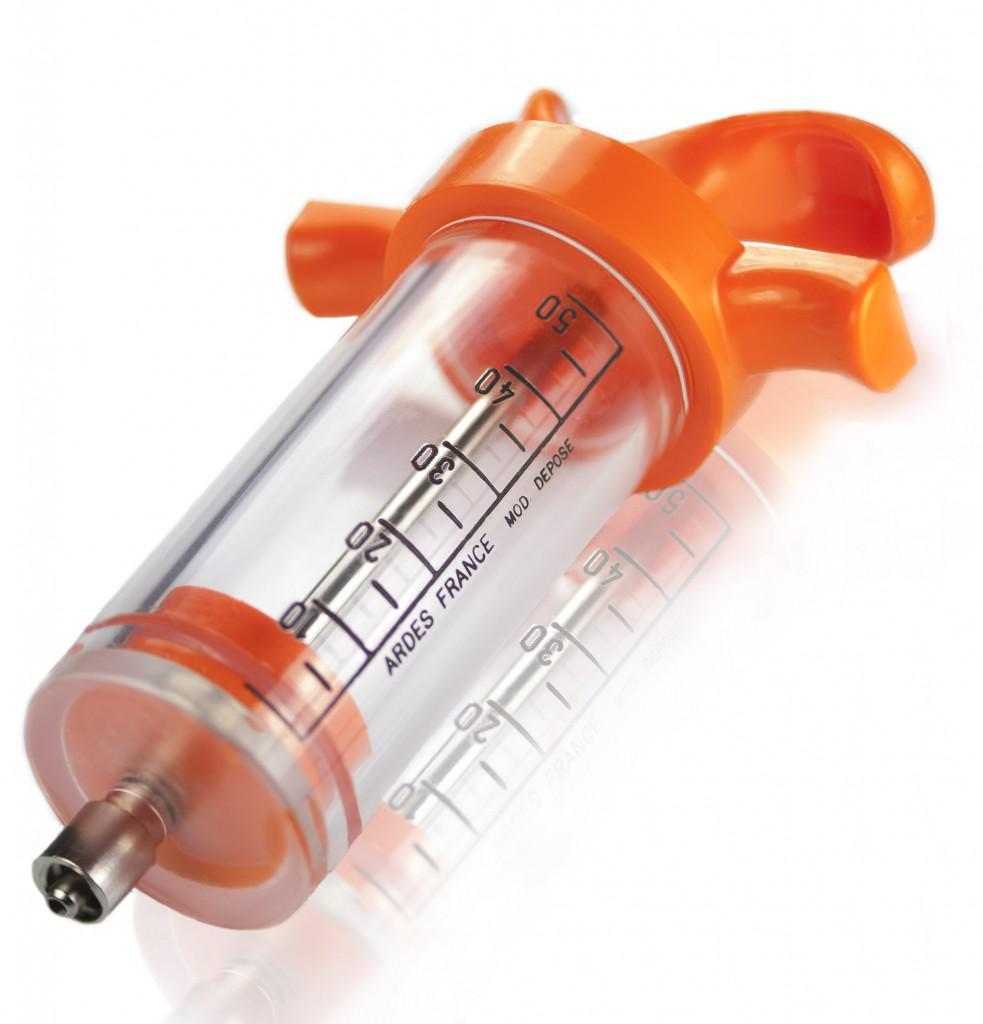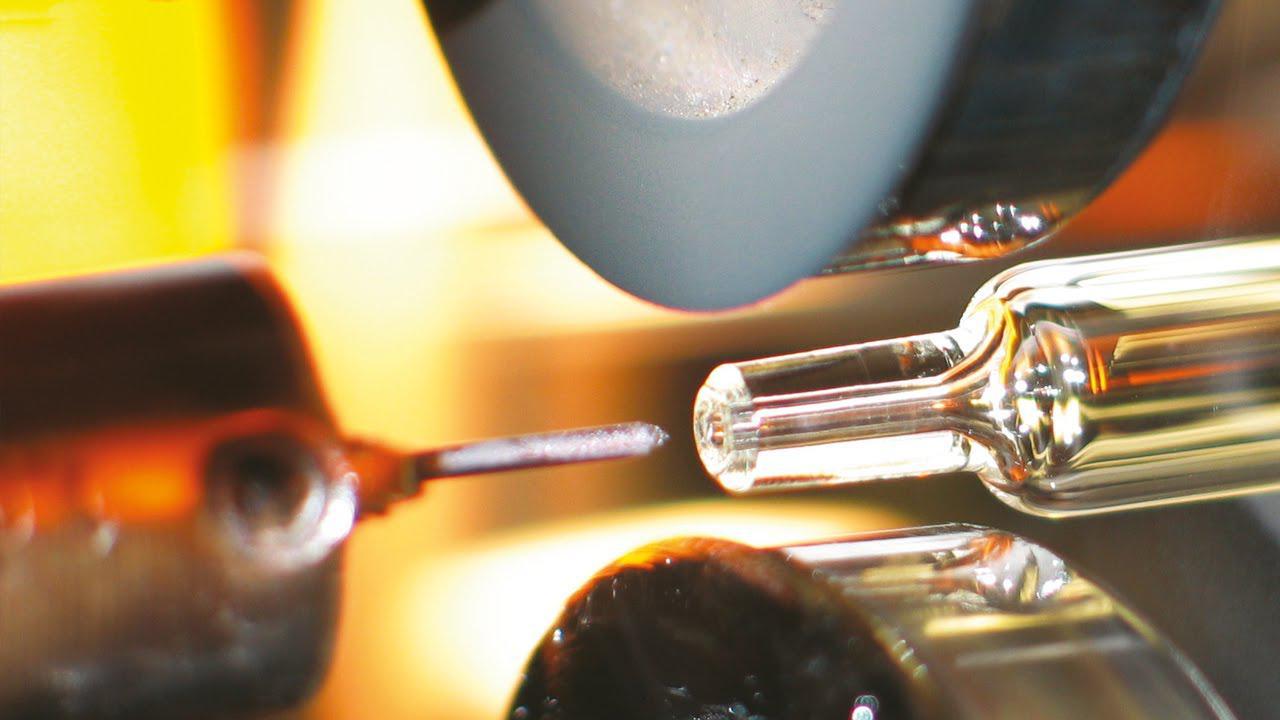The first image is the image on the left, the second image is the image on the right. Evaluate the accuracy of this statement regarding the images: "The left image shows a clear cylinder with colored plastic on each end, and the right image shows something with a rightward-facing point". Is it true? Answer yes or no. Yes. 